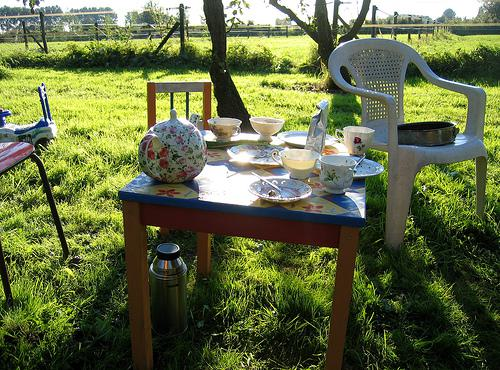Can you describe the setting of this image? This image captures a charming outdoor setting, likely a personal garden or a small rural property. It features a rustic blue table adorned with various teacups, plates, and a teapot, suggesting a tea party has just occurred or is about to. The chair and open gate in the background give it a welcoming, casual feel. 